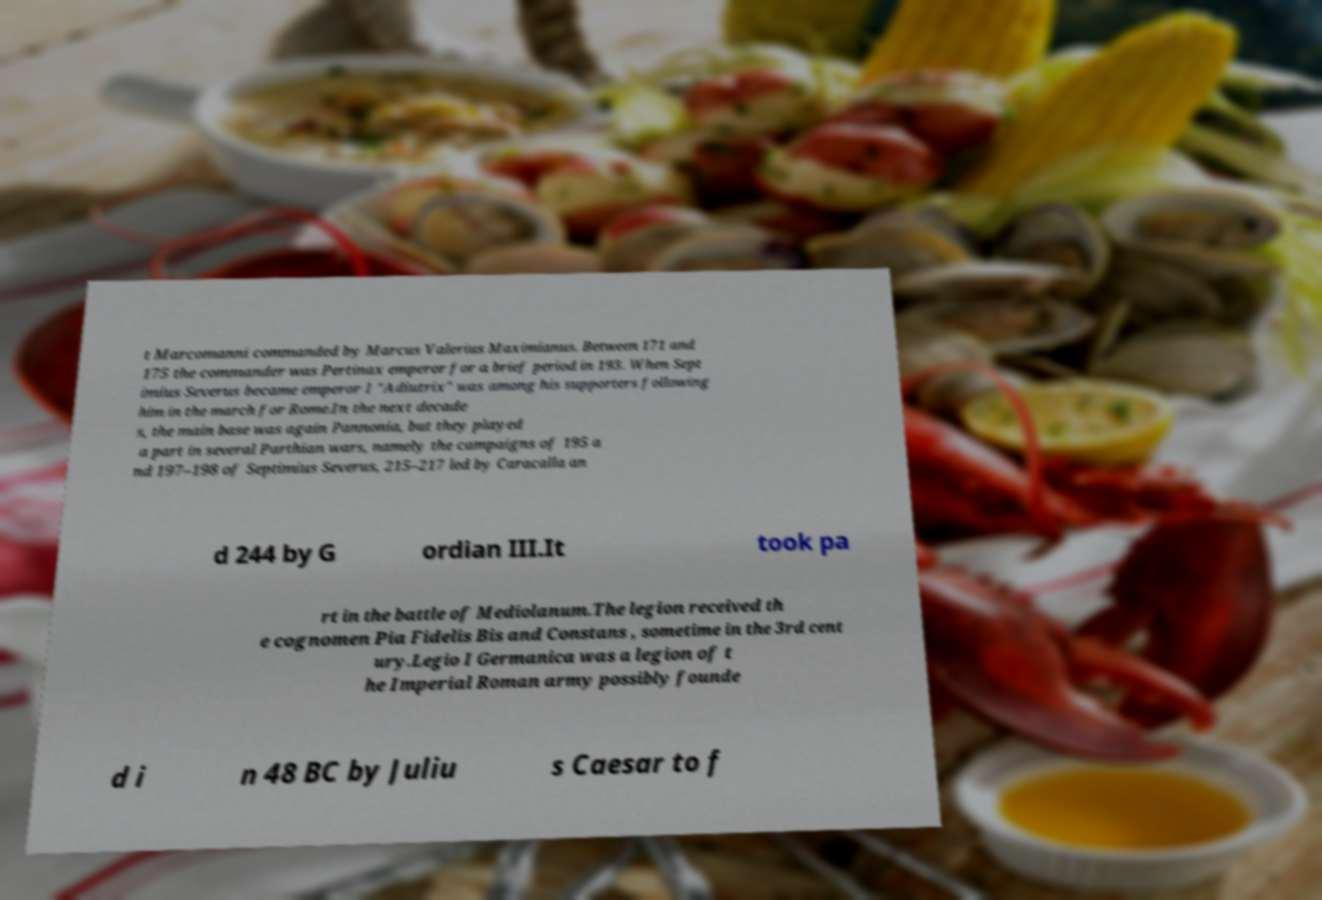Could you extract and type out the text from this image? t Marcomanni commanded by Marcus Valerius Maximianus. Between 171 and 175 the commander was Pertinax emperor for a brief period in 193. When Sept imius Severus became emperor I "Adiutrix" was among his supporters following him in the march for Rome.In the next decade s, the main base was again Pannonia, but they played a part in several Parthian wars, namely the campaigns of 195 a nd 197–198 of Septimius Severus, 215–217 led by Caracalla an d 244 by G ordian III.It took pa rt in the battle of Mediolanum.The legion received th e cognomen Pia Fidelis Bis and Constans , sometime in the 3rd cent ury.Legio I Germanica was a legion of t he Imperial Roman army possibly founde d i n 48 BC by Juliu s Caesar to f 